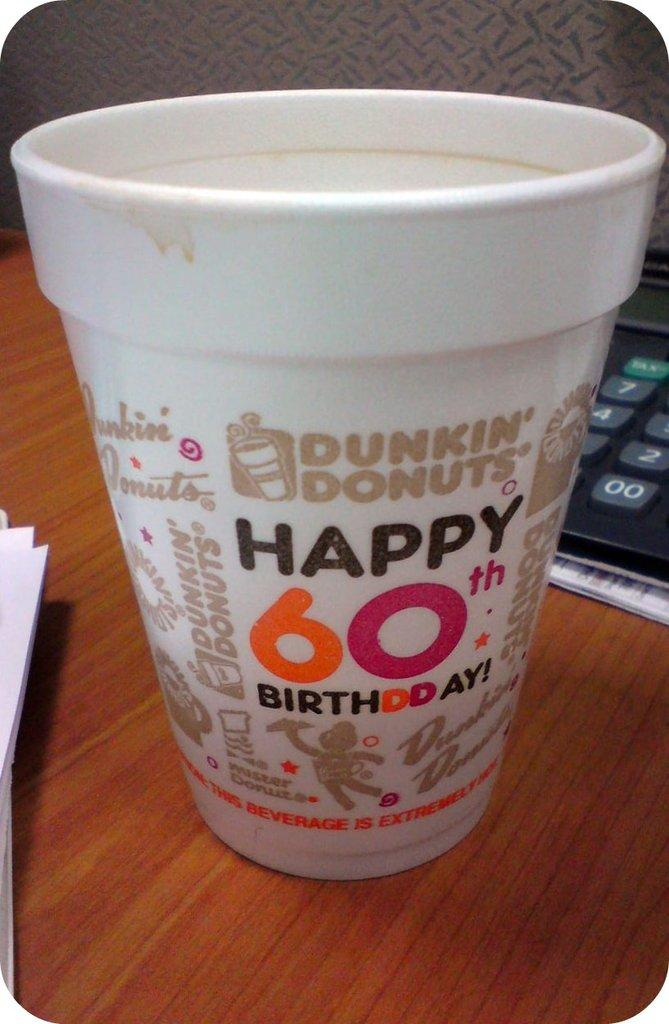What is one of the objects placed on the wooden board in the image? There is a cup in the image. What other object can be seen on the wooden board? There is a calculator in the image. What else is present on the wooden board? There are papers in the image. What can be seen in the background of the image? There is a wall visible in the background of the image. Can you see a river and a boat in the image? No, there is no river or boat present in the image. What type of cream is being used on the wooden board in the image? There is no cream visible in the image; it only features a cup, calculator, papers, and a wooden board. 